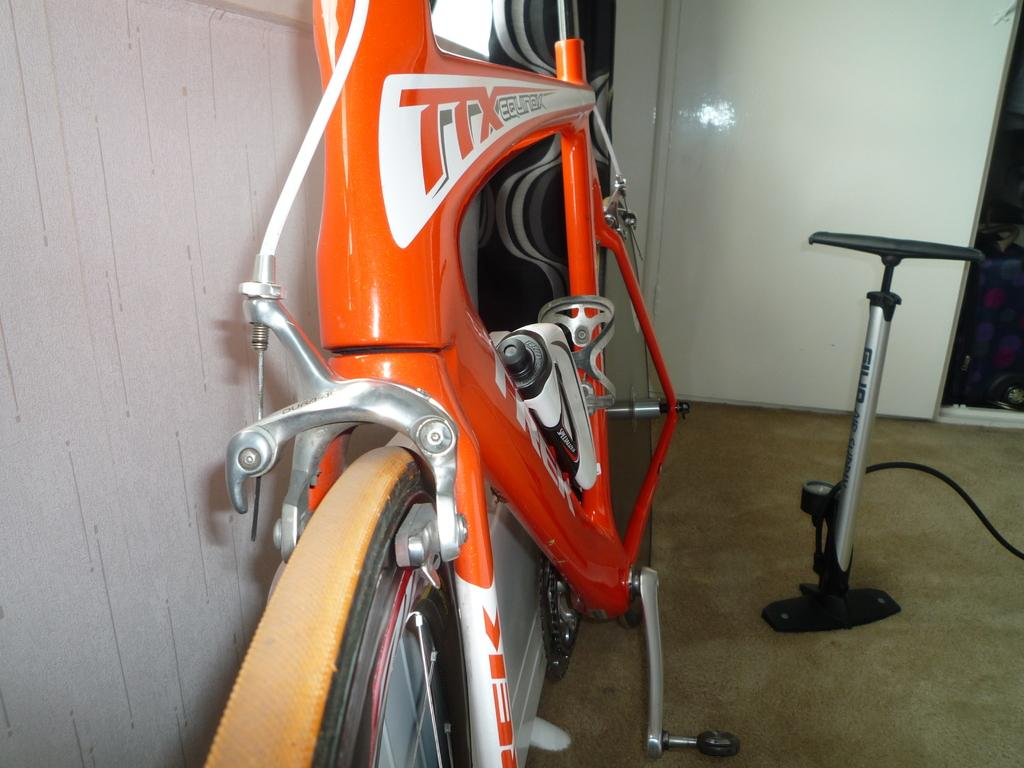What type of vehicle is in the image? There is a cycle in the image. What color is the cycle? The cycle is orange in color. What object can be seen on the right side of the image? There appears to be an air pump on the right side of the image. Can you see any magic happening with the cycle in the image? There is no magic present in the image; it is a regular cycle in an orange color. 